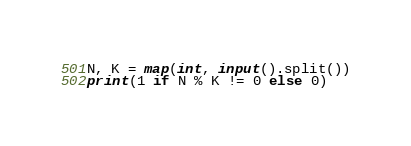Convert code to text. <code><loc_0><loc_0><loc_500><loc_500><_Python_>N, K = map(int, input().split())
print(1 if N % K != 0 else 0)
</code> 